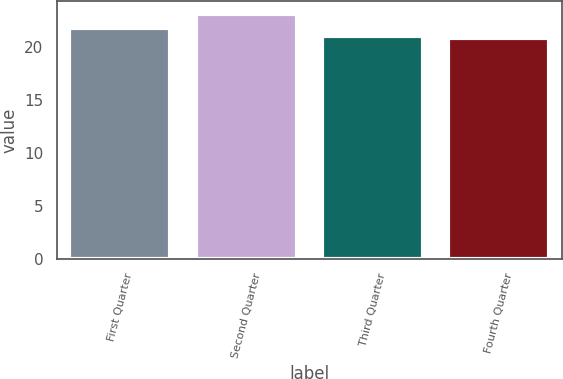Convert chart. <chart><loc_0><loc_0><loc_500><loc_500><bar_chart><fcel>First Quarter<fcel>Second Quarter<fcel>Third Quarter<fcel>Fourth Quarter<nl><fcel>21.8<fcel>23.15<fcel>21.04<fcel>20.81<nl></chart> 